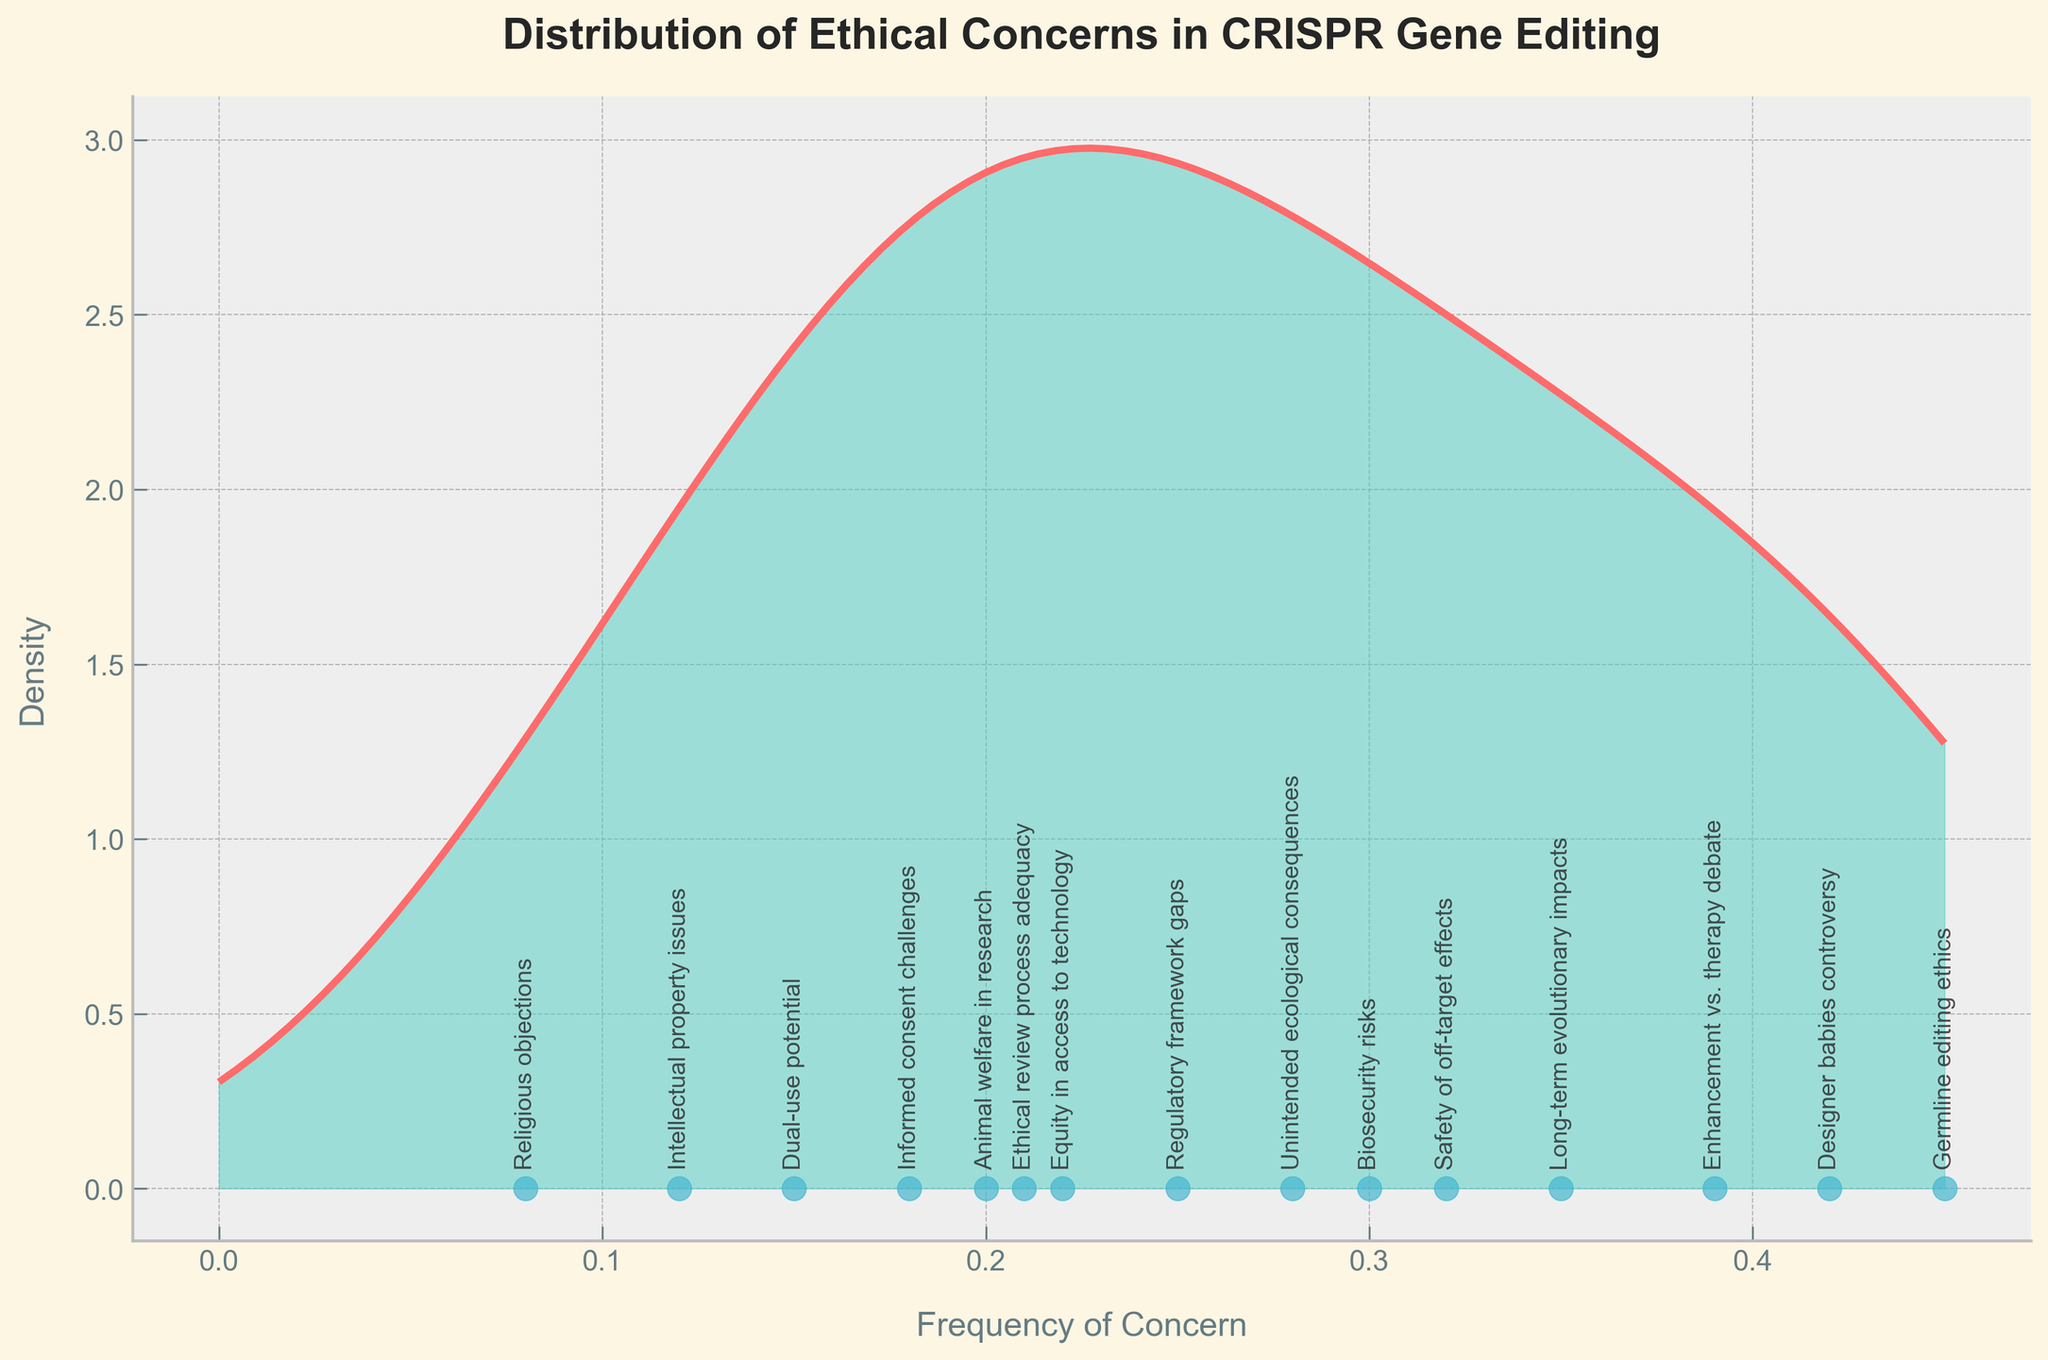What is the title of the figure? The title of the figure is usually placed at the top and can be directly read. In this case, it's "Distribution of Ethical Concerns in CRISPR Gene Editing".
Answer: Distribution of Ethical Concerns in CRISPR Gene Editing What does the x-axis label represent? The x-axis label is generally displayed below the axis and denotes what the x-values signify. Here, it is "Frequency of Concern".
Answer: Frequency of Concern How many ethical concerns are plotted? Counting the number of data points (scatter points) on the x-axis will give the number of ethical concerns. The concerns are annotated, and there are 14 annotations.
Answer: 14 Which ethical concern has the highest frequency? By observing the annotated scatter points along the x-axis, "Germline editing ethics" is the furthest to the right, indicating the highest frequency.
Answer: Germline editing ethics Which two ethical concerns have a similar frequency of approximately 0.20? By looking at the x-axis positions, "Animal welfare in research" and "Ethical review process adequacy" are very close together around the 0.20 mark.
Answer: Animal welfare in research and Ethical review process adequacy What is the range of frequency values? The smallest and largest values among the scatter points represent the range. The smallest is "Religious objections" at 0.08, and the largest is "Germline editing ethics" at 0.45, thus the range is 0.45 - 0.08.
Answer: 0.08 to 0.45 What color is the density plot line? The line color of the density plot can be described visually as it appears red.
Answer: Red Which ethical concern has a lower frequency than "Regulatory framework gaps" but higher frequency than "Animal welfare in research"? By checking the x-axis annotations, "Designer babies controversy" (0.42) fits this requirement.
Answer: Designer babies controversy How does the density curve's peak relate to data points? The highest peak in the density curve indicates where the majority of the data points cluster on the x-axis. The peak appears around the 0.30 value of frequency, aligning with concerns like "Safety of off-target effects" and "Biosecurity risks".
Answer: Around 0.30 frequency 